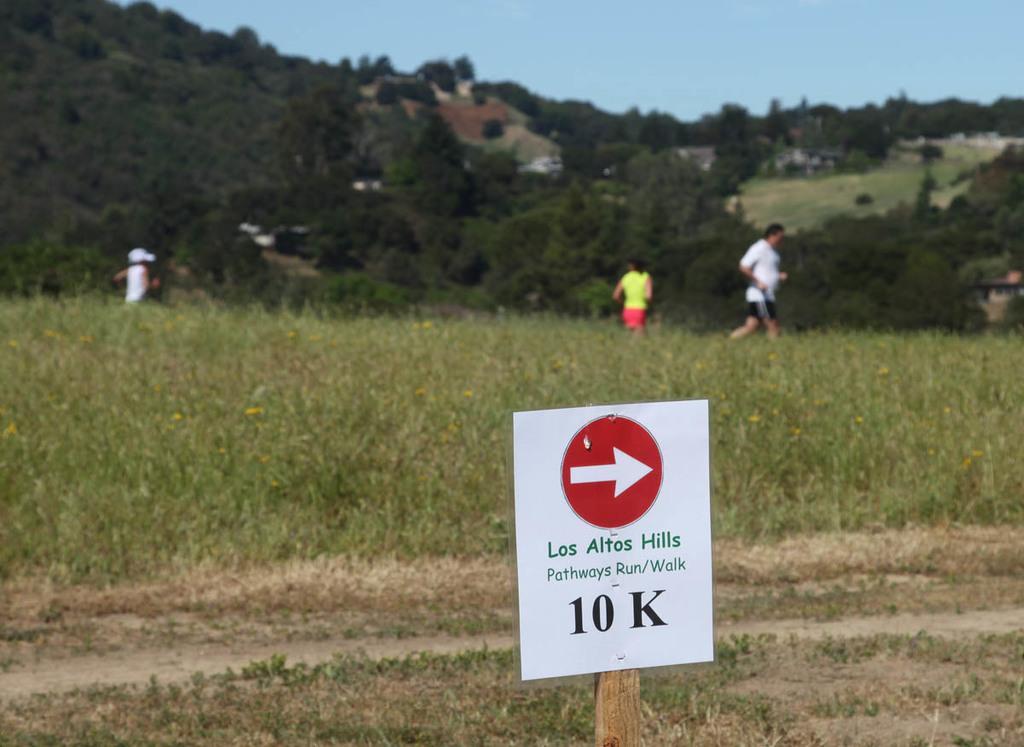Can you describe this image briefly? In the image we can see there is a hoarding kept on the wooden stick and its written ¨10 k¨ on it. There are plants on the ground and there are people standing on the ground. Behind there are trees and there is clear sky on the top. 